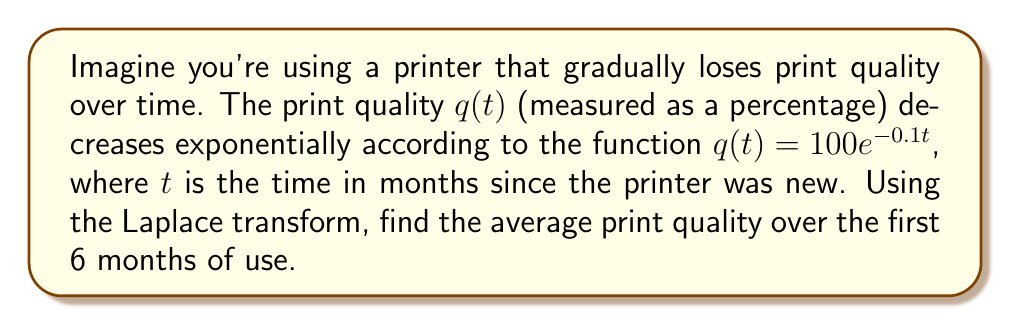Can you solve this math problem? To solve this problem using Laplace transforms, we'll follow these steps:

1) First, recall that the Laplace transform of a function $f(t)$ is defined as:

   $$F(s) = \mathcal{L}\{f(t)\} = \int_0^\infty e^{-st}f(t)dt$$

2) The average value of a function over an interval $[0,T]$ is given by:

   $$\text{Average} = \frac{1}{T}\int_0^T f(t)dt$$

3) We can use the Laplace transform to find this integral. Specifically:

   $$\int_0^T f(t)dt = \mathcal{L}^{-1}\left\{\frac{F(s)}{s}\right\}\bigg|_{t=T}$$

4) So, let's find the Laplace transform of $q(t) = 100e^{-0.1t}$:

   $$Q(s) = \mathcal{L}\{100e^{-0.1t}\} = \frac{100}{s+0.1}$$

5) Now, we need to find $\frac{Q(s)}{s}$:

   $$\frac{Q(s)}{s} = \frac{100}{s(s+0.1)}$$

6) The inverse Laplace transform of this is:

   $$\mathcal{L}^{-1}\left\{\frac{100}{s(s+0.1)}\right\} = 1000 - 1000e^{-0.1t}$$

7) Evaluating this at $t=6$ (for 6 months):

   $$1000 - 1000e^{-0.1(6)} = 1000 - 1000e^{-0.6} \approx 451.19$$

8) Finally, to get the average, we divide by $T=6$:

   $$\text{Average} = \frac{451.19}{6} \approx 75.20$$
Answer: The average print quality over the first 6 months is approximately 75.20%. 